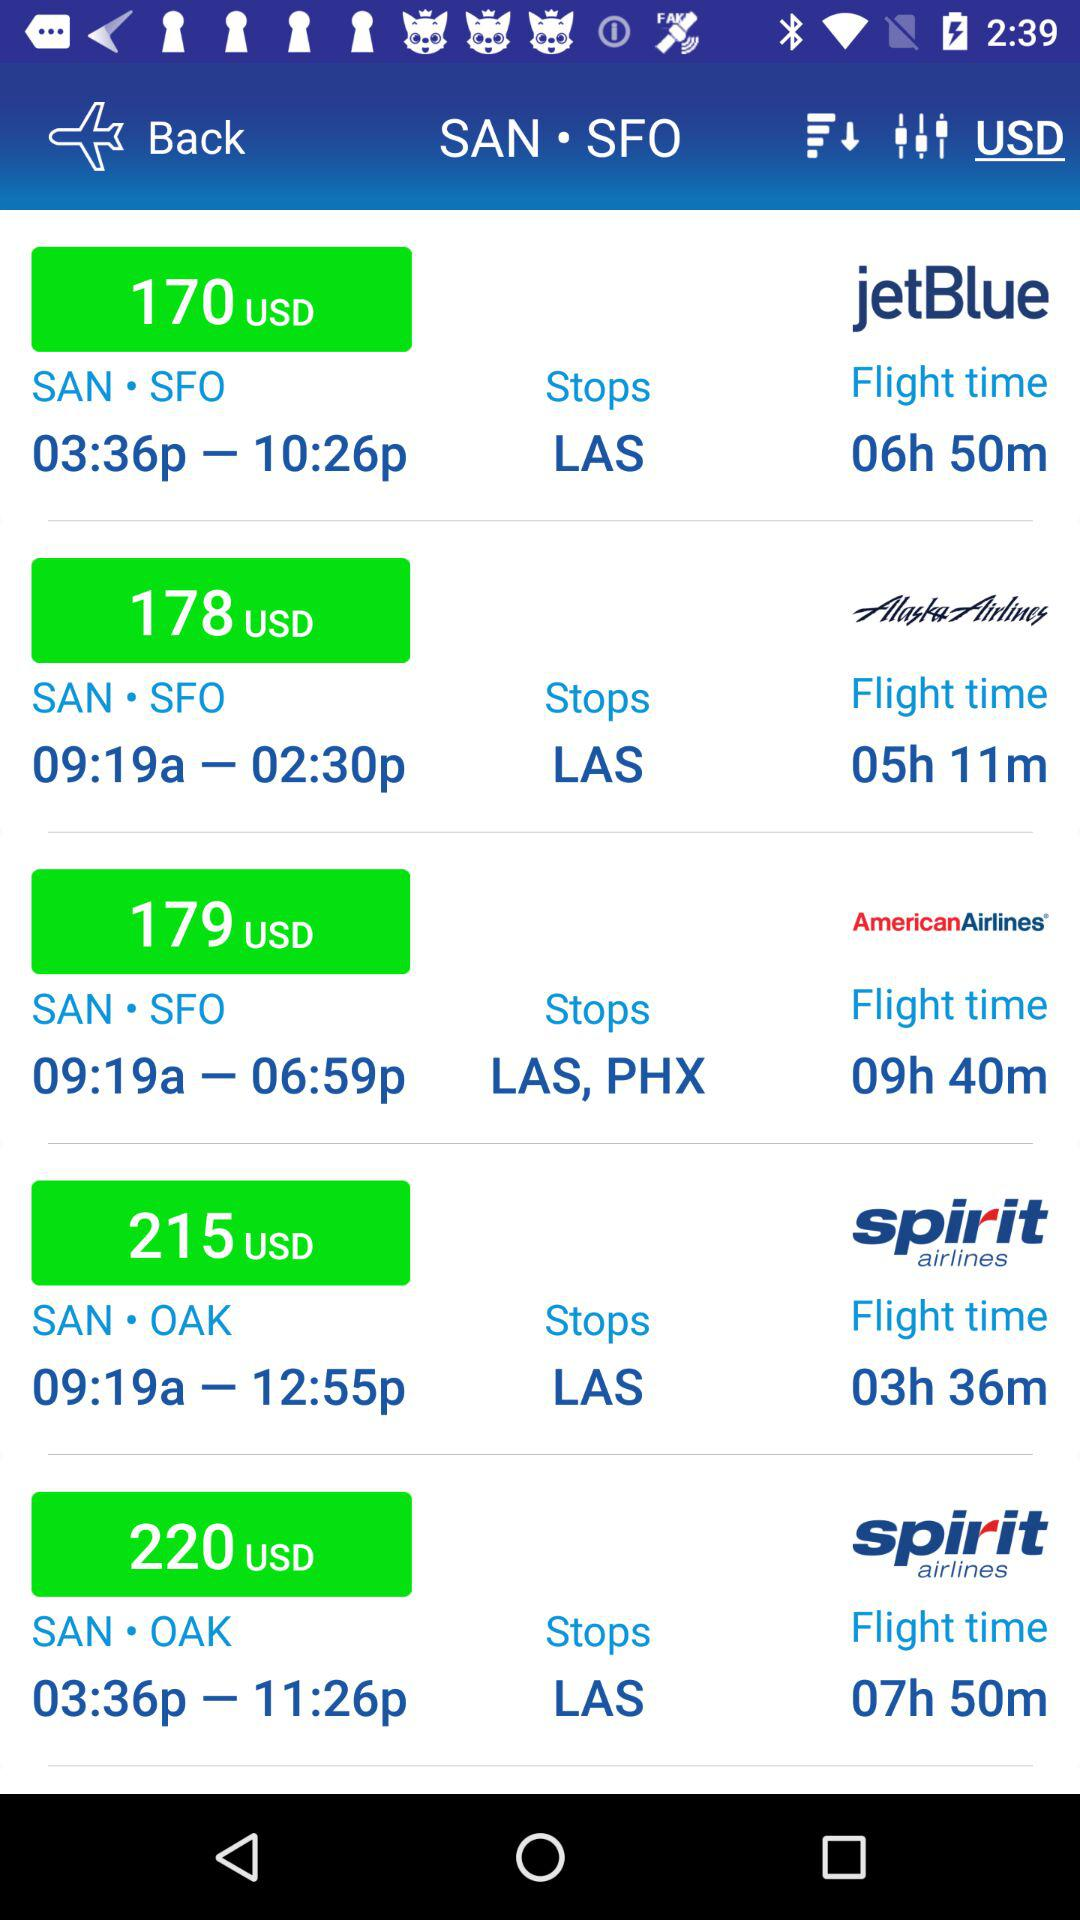What is the duration of the American Airlines flight? The duration of the American Airlines flight is 9 hours 40 minutes. 